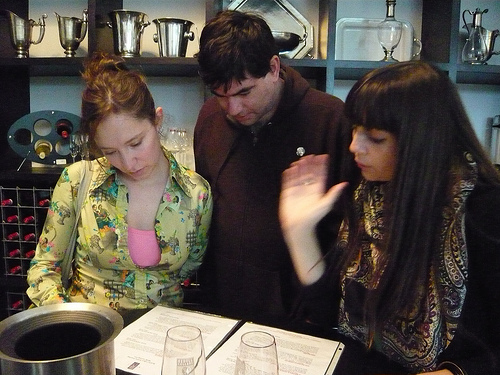<image>
Is there a girl on the man? No. The girl is not positioned on the man. They may be near each other, but the girl is not supported by or resting on top of the man. Is the man to the left of the woman? Yes. From this viewpoint, the man is positioned to the left side relative to the woman. 